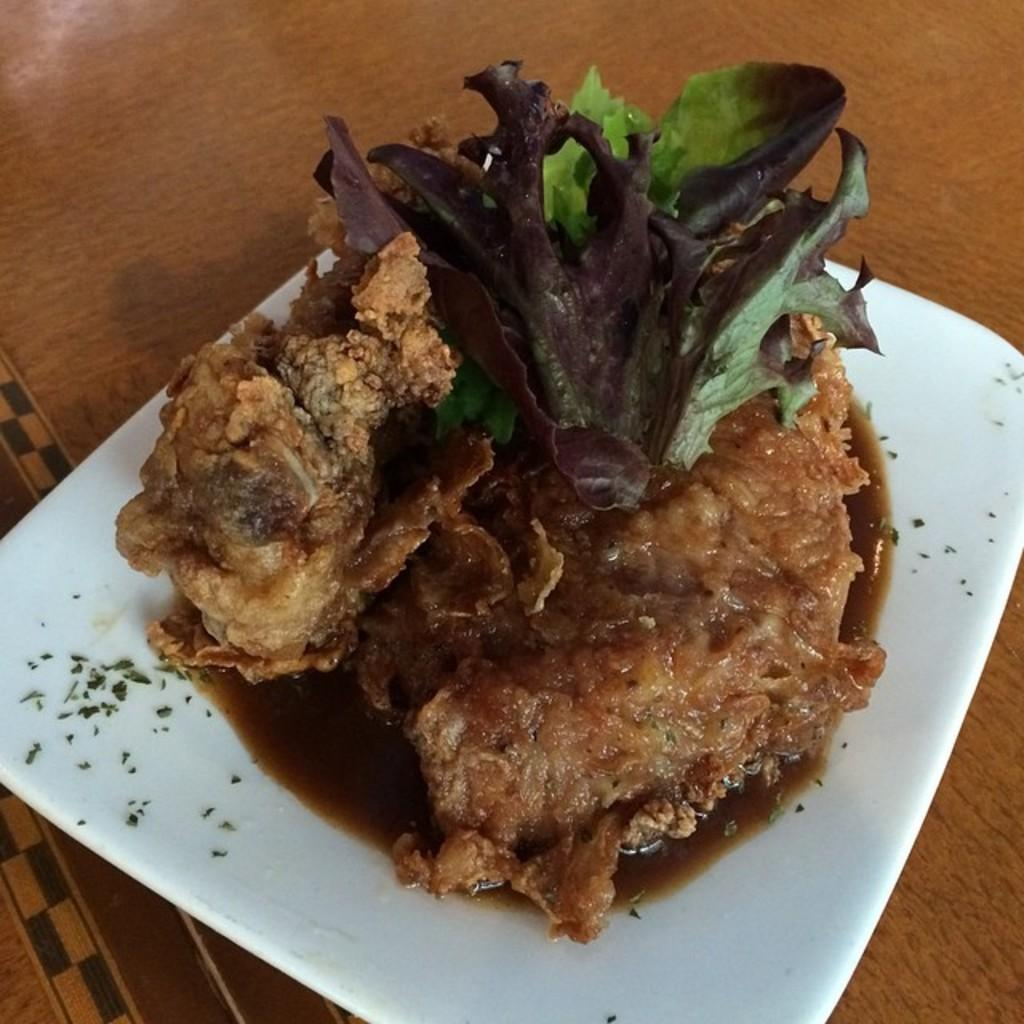What is on the table in the image? There is a plate on the table. What is on the plate? The plate contains a dish. What can be observed about the dish? The dish has green leaves and sauce. What type of lettuce is growing in the patch next to the table in the image? There is no patch or lettuce present in the image; the image only shows a plate with a dish containing green leaves and sauce. 